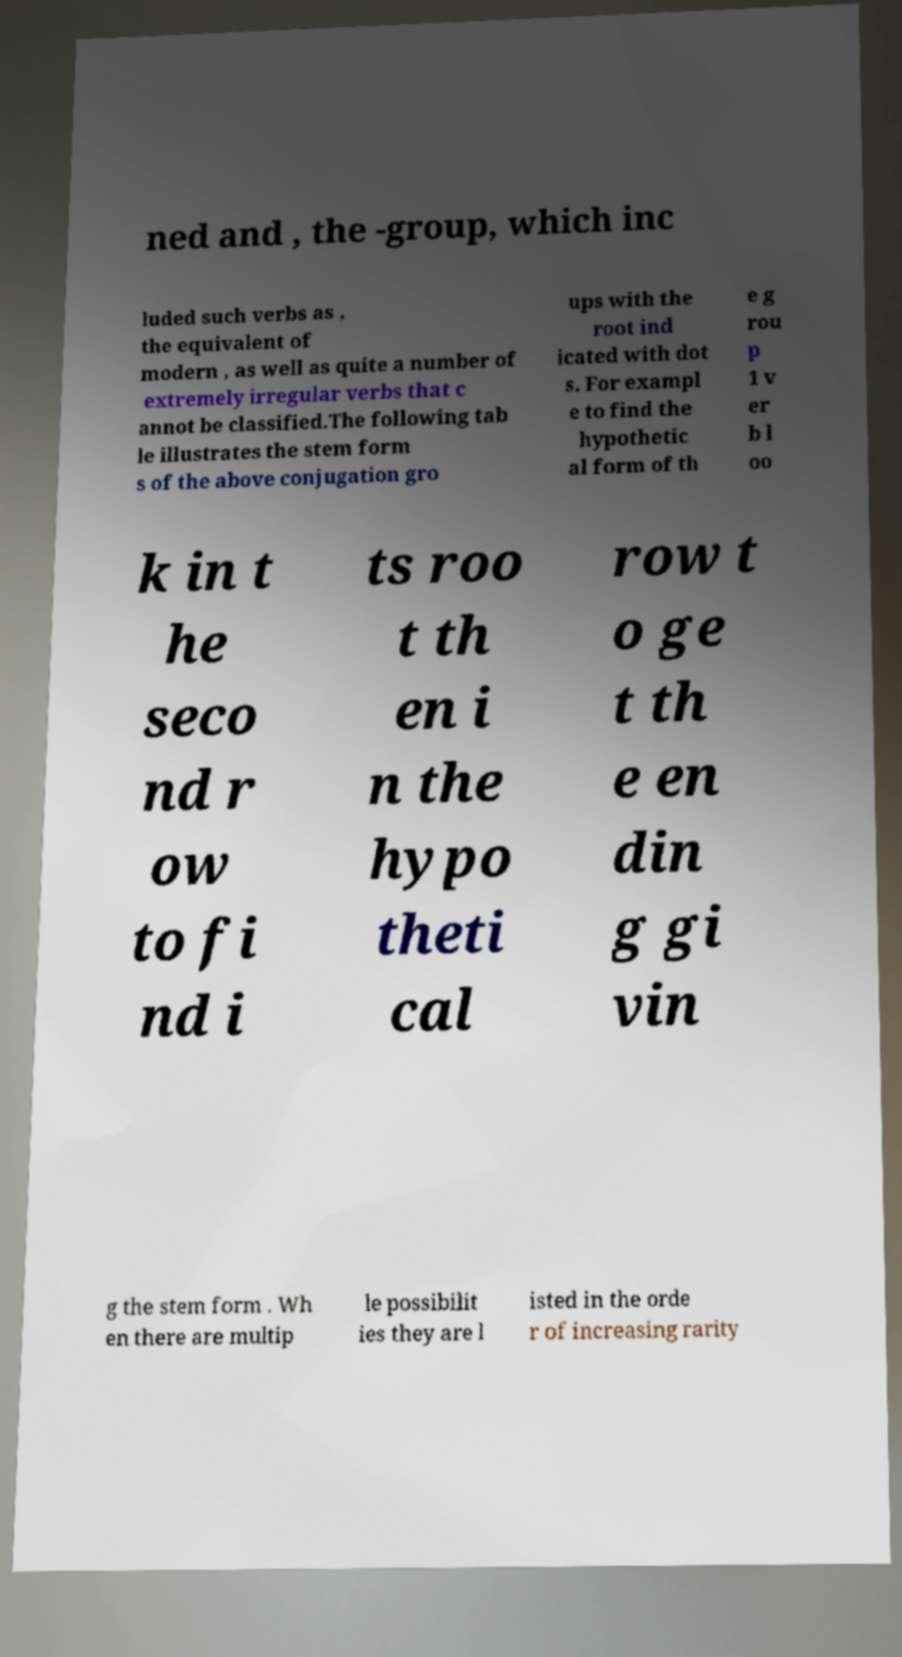Please read and relay the text visible in this image. What does it say? ned and , the -group, which inc luded such verbs as , the equivalent of modern , as well as quite a number of extremely irregular verbs that c annot be classified.The following tab le illustrates the stem form s of the above conjugation gro ups with the root ind icated with dot s. For exampl e to find the hypothetic al form of th e g rou p 1 v er b l oo k in t he seco nd r ow to fi nd i ts roo t th en i n the hypo theti cal row t o ge t th e en din g gi vin g the stem form . Wh en there are multip le possibilit ies they are l isted in the orde r of increasing rarity 